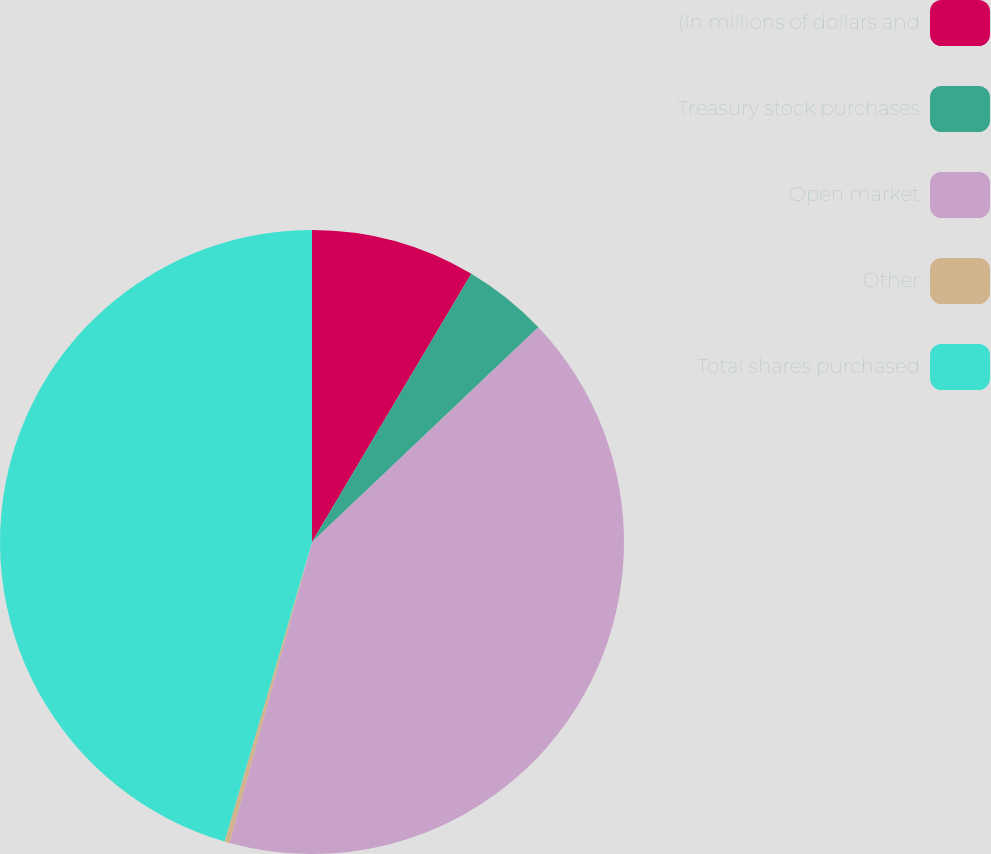<chart> <loc_0><loc_0><loc_500><loc_500><pie_chart><fcel>(In millions of dollars and<fcel>Treasury stock purchases<fcel>Open market<fcel>Other<fcel>Total shares purchased<nl><fcel>8.53%<fcel>4.39%<fcel>41.34%<fcel>0.26%<fcel>45.48%<nl></chart> 